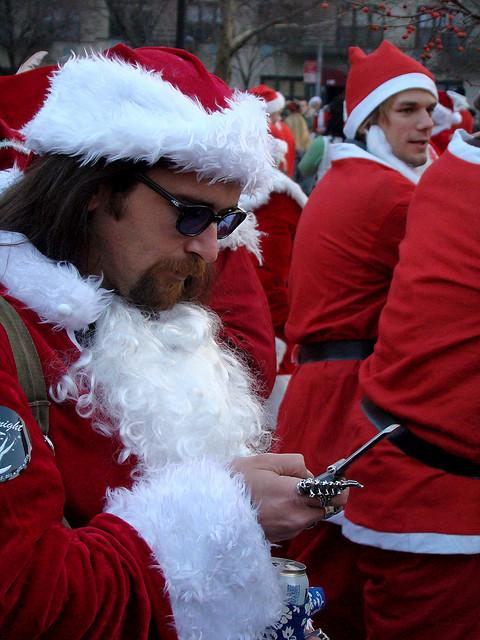What Christmas character are these people all dressed up as? Please explain your reasoning. santa clause. They have red suits with white fur and beards 